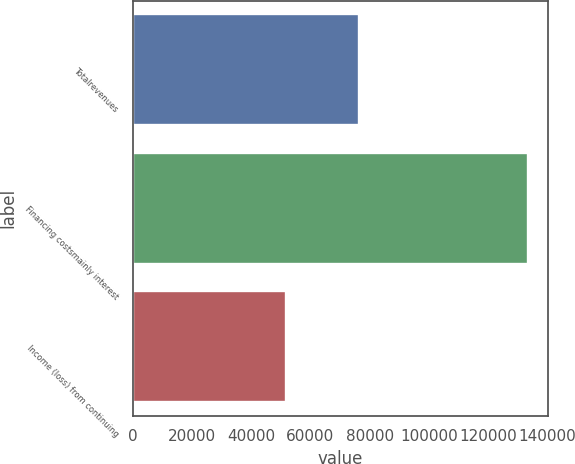Convert chart to OTSL. <chart><loc_0><loc_0><loc_500><loc_500><bar_chart><fcel>Totalrevenues<fcel>Financing costsmainly interest<fcel>Income (loss) from continuing<nl><fcel>76287<fcel>133558<fcel>51570<nl></chart> 